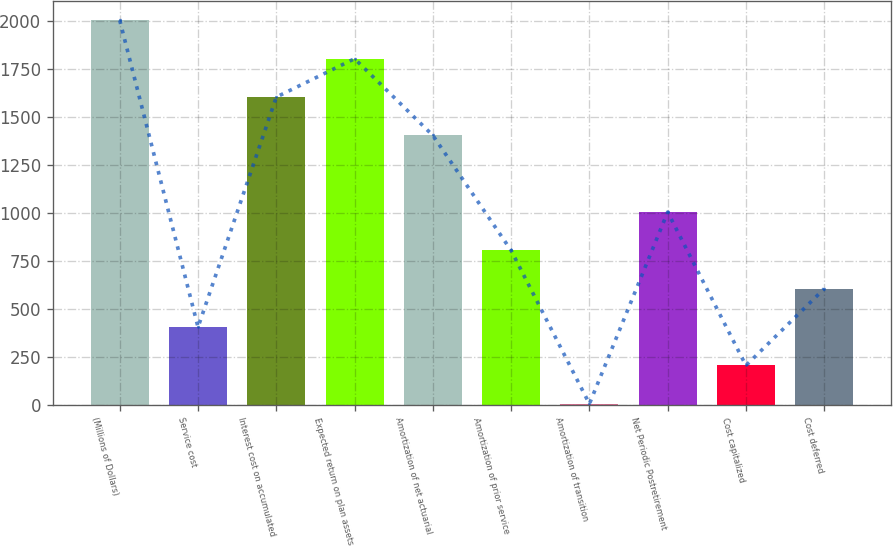Convert chart to OTSL. <chart><loc_0><loc_0><loc_500><loc_500><bar_chart><fcel>(Millions of Dollars)<fcel>Service cost<fcel>Interest cost on accumulated<fcel>Expected return on plan assets<fcel>Amortization of net actuarial<fcel>Amortization of prior service<fcel>Amortization of transition<fcel>Net Periodic Postretirement<fcel>Cost capitalized<fcel>Cost deferred<nl><fcel>2004<fcel>404<fcel>1604<fcel>1804<fcel>1404<fcel>804<fcel>4<fcel>1004<fcel>204<fcel>604<nl></chart> 